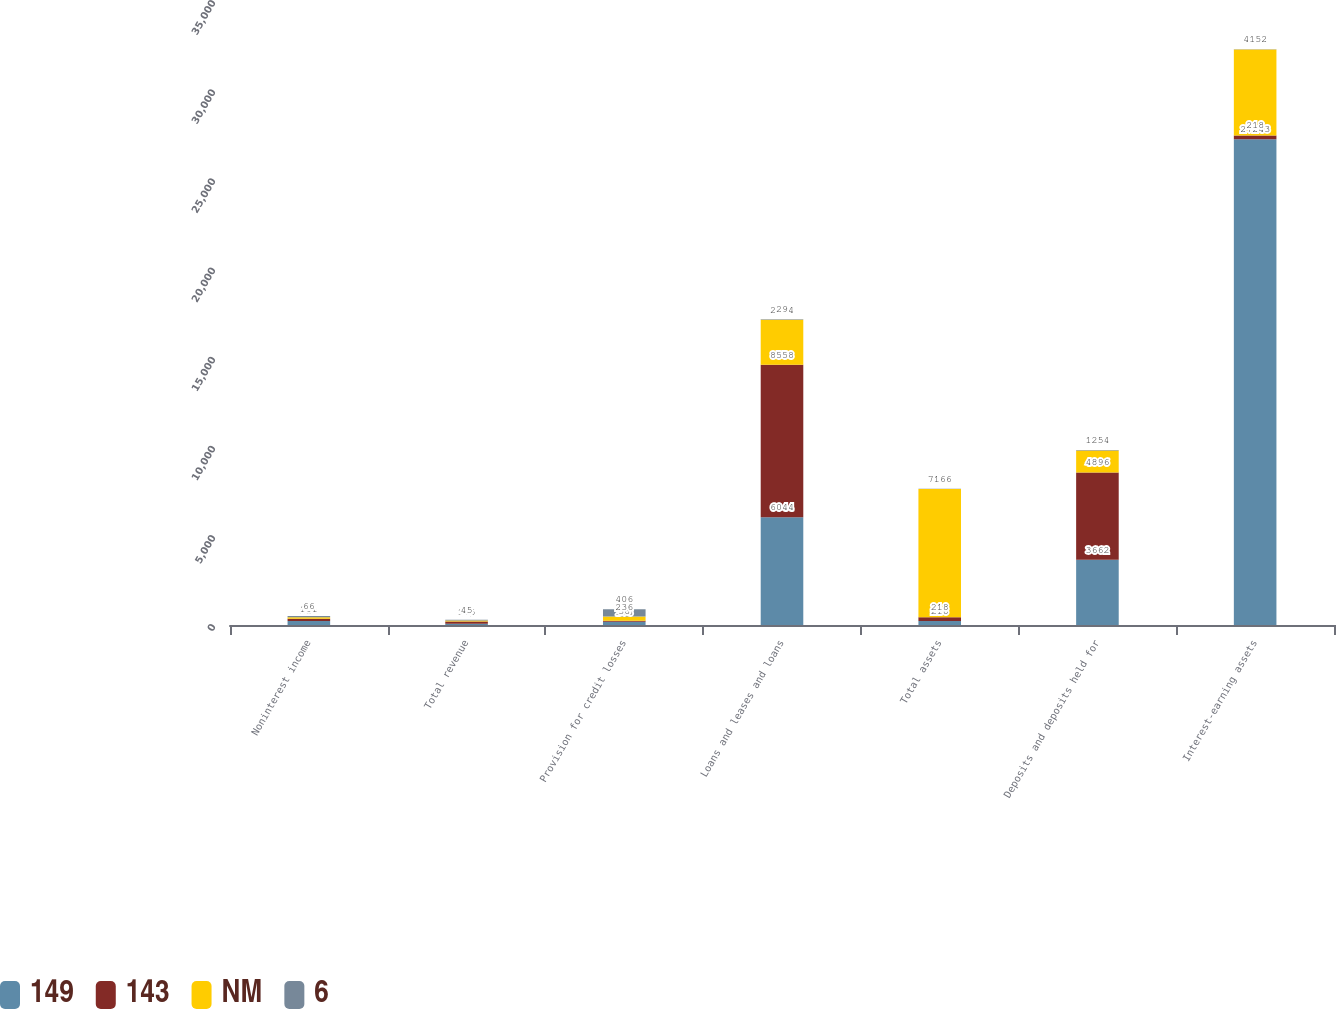Convert chart to OTSL. <chart><loc_0><loc_0><loc_500><loc_500><stacked_bar_chart><ecel><fcel>Noninterest income<fcel>Total revenue<fcel>Provision for credit losses<fcel>Loans and leases and loans<fcel>Total assets<fcel>Deposits and deposits held for<fcel>Interest-earning assets<nl><fcel>149<fcel>218<fcel>69<fcel>178<fcel>6044<fcel>218<fcel>3662<fcel>27243<nl><fcel>143<fcel>131<fcel>125<fcel>58<fcel>8558<fcel>218<fcel>4896<fcel>218<nl><fcel>NM<fcel>87<fcel>56<fcel>236<fcel>2514<fcel>7196<fcel>1234<fcel>4822<nl><fcel>6<fcel>66<fcel>45<fcel>406<fcel>29<fcel>16<fcel>25<fcel>15<nl></chart> 